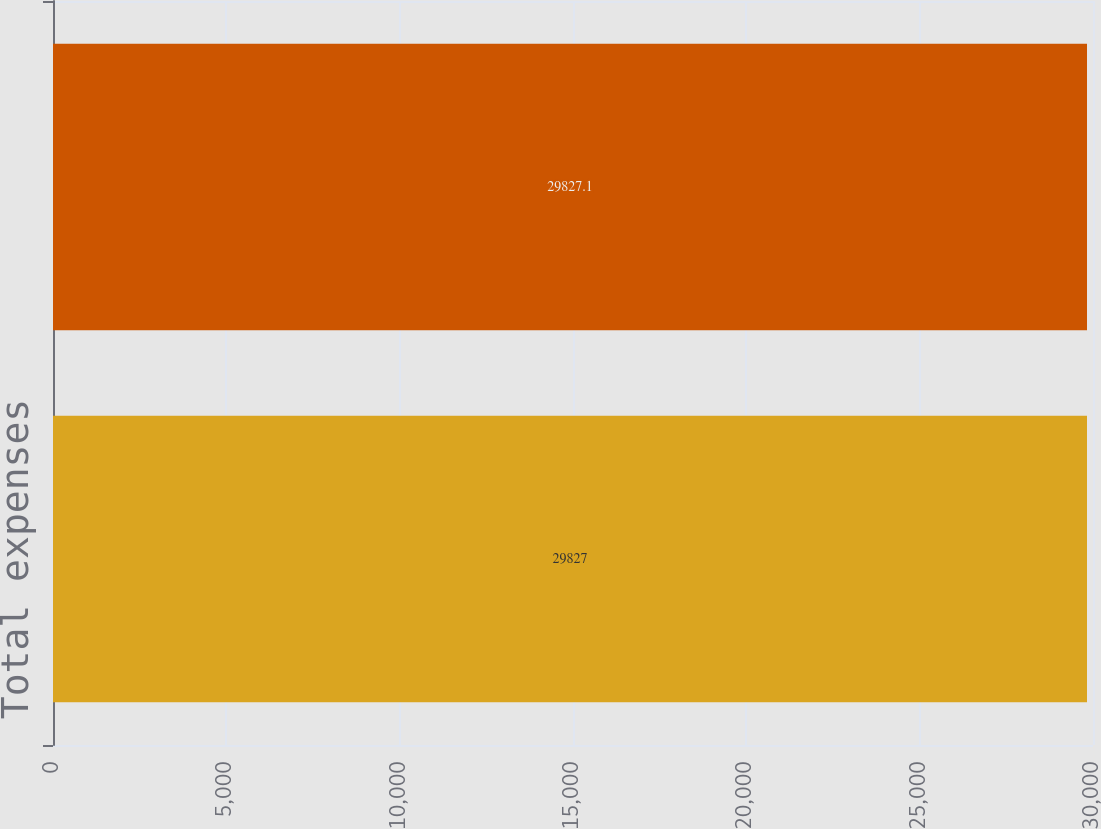Convert chart. <chart><loc_0><loc_0><loc_500><loc_500><bar_chart><fcel>Total expenses<fcel>Sub total<nl><fcel>29827<fcel>29827.1<nl></chart> 